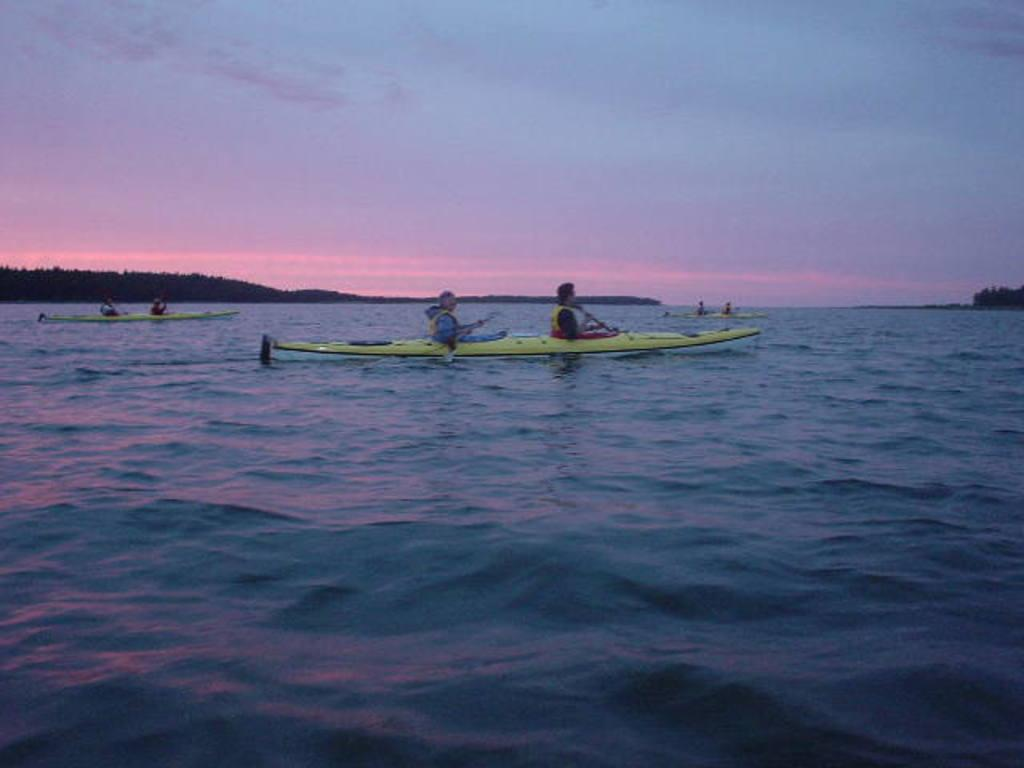What type of vehicles are in the water in the image? There are boats in the water in the image. What are the people in the boats doing? People are seated in the boats. What is the condition of the sky in the image? The sky is cloudy in the image. Can you tell me how many people are jumping off the boats in the image? There is no indication in the image that people are jumping off the boats; they are seated in the boats. What type of agreement is being discussed by the people in the boats in the image? There is no indication in the image that people are discussing any agreements; they are simply seated in the boats. 